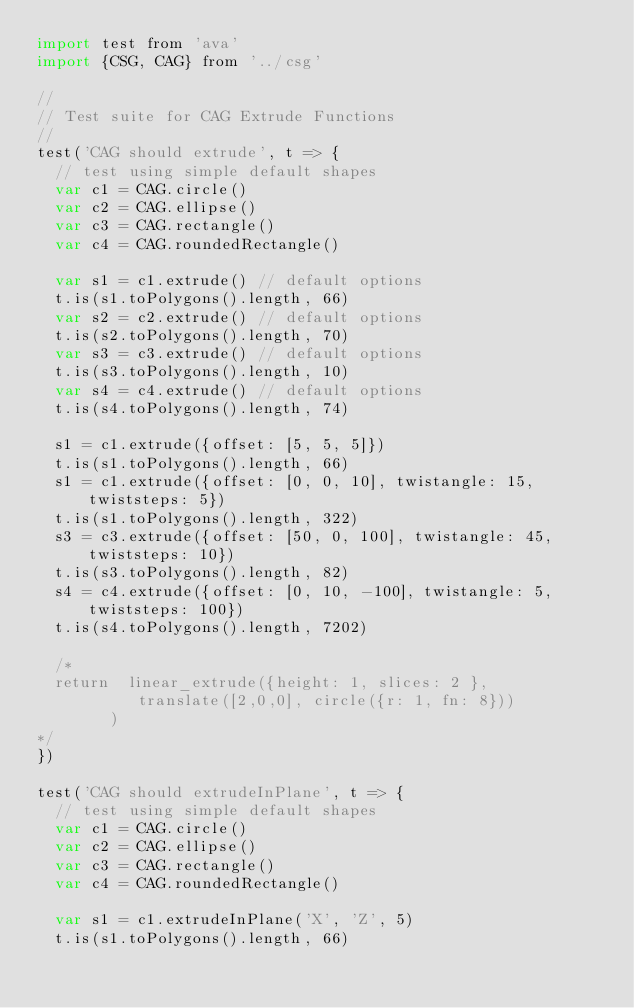Convert code to text. <code><loc_0><loc_0><loc_500><loc_500><_JavaScript_>import test from 'ava'
import {CSG, CAG} from '../csg'

//
// Test suite for CAG Extrude Functions
//
test('CAG should extrude', t => {
  // test using simple default shapes
  var c1 = CAG.circle()
  var c2 = CAG.ellipse()
  var c3 = CAG.rectangle()
  var c4 = CAG.roundedRectangle()

  var s1 = c1.extrude() // default options
  t.is(s1.toPolygons().length, 66)
  var s2 = c2.extrude() // default options
  t.is(s2.toPolygons().length, 70)
  var s3 = c3.extrude() // default options
  t.is(s3.toPolygons().length, 10)
  var s4 = c4.extrude() // default options
  t.is(s4.toPolygons().length, 74)

  s1 = c1.extrude({offset: [5, 5, 5]})
  t.is(s1.toPolygons().length, 66)
  s1 = c1.extrude({offset: [0, 0, 10], twistangle: 15, twiststeps: 5})
  t.is(s1.toPolygons().length, 322)
  s3 = c3.extrude({offset: [50, 0, 100], twistangle: 45, twiststeps: 10})
  t.is(s3.toPolygons().length, 82)
  s4 = c4.extrude({offset: [0, 10, -100], twistangle: 5, twiststeps: 100})
  t.is(s4.toPolygons().length, 7202)

  /*
  return  linear_extrude({height: 1, slices: 2 },
           translate([2,0,0], circle({r: 1, fn: 8}))
        )
*/
})

test('CAG should extrudeInPlane', t => {
  // test using simple default shapes
  var c1 = CAG.circle()
  var c2 = CAG.ellipse()
  var c3 = CAG.rectangle()
  var c4 = CAG.roundedRectangle()

  var s1 = c1.extrudeInPlane('X', 'Z', 5)
  t.is(s1.toPolygons().length, 66)</code> 